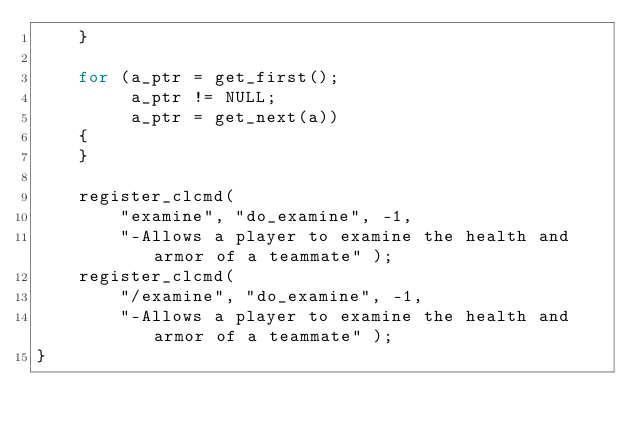Convert code to text. <code><loc_0><loc_0><loc_500><loc_500><_C_>    }

    for (a_ptr = get_first();
         a_ptr != NULL;
         a_ptr = get_next(a))
    {
    }

    register_clcmd(
        "examine", "do_examine", -1,
        "-Allows a player to examine the health and armor of a teammate" );
    register_clcmd(
        "/examine", "do_examine", -1,
        "-Allows a player to examine the health and armor of a teammate" );
}

</code> 